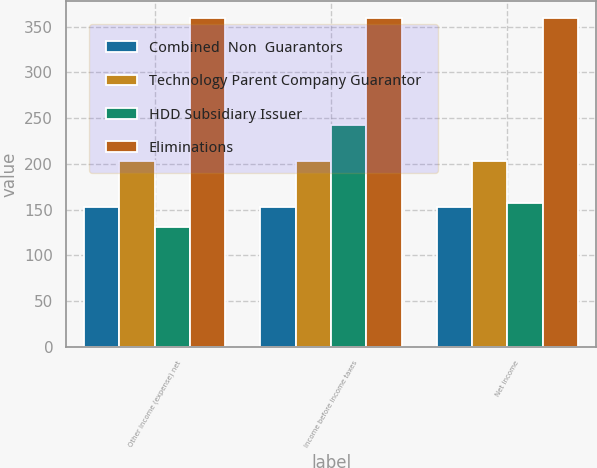Convert chart to OTSL. <chart><loc_0><loc_0><loc_500><loc_500><stacked_bar_chart><ecel><fcel>Other income (expense) net<fcel>Income before income taxes<fcel>Net income<nl><fcel>Combined  Non  Guarantors<fcel>153<fcel>153<fcel>153<nl><fcel>Technology Parent Company Guarantor<fcel>203<fcel>203<fcel>203<nl><fcel>HDD Subsidiary Issuer<fcel>131<fcel>243<fcel>157<nl><fcel>Eliminations<fcel>360<fcel>360<fcel>360<nl></chart> 